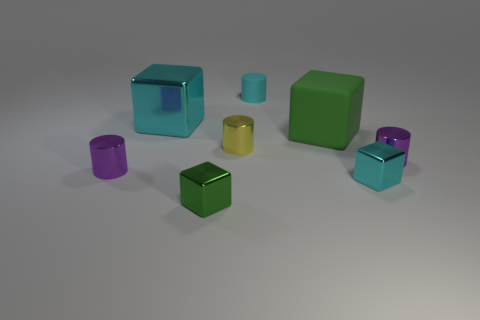Subtract all metal blocks. How many blocks are left? 1 Subtract all green cubes. How many cubes are left? 2 Add 1 large blue metallic things. How many objects exist? 9 Subtract 3 cylinders. How many cylinders are left? 1 Add 1 big cubes. How many big cubes are left? 3 Add 3 green shiny cubes. How many green shiny cubes exist? 4 Subtract 0 brown cylinders. How many objects are left? 8 Subtract all purple blocks. Subtract all gray cylinders. How many blocks are left? 4 Subtract all red cylinders. How many green cubes are left? 2 Subtract all small gray rubber spheres. Subtract all tiny cylinders. How many objects are left? 4 